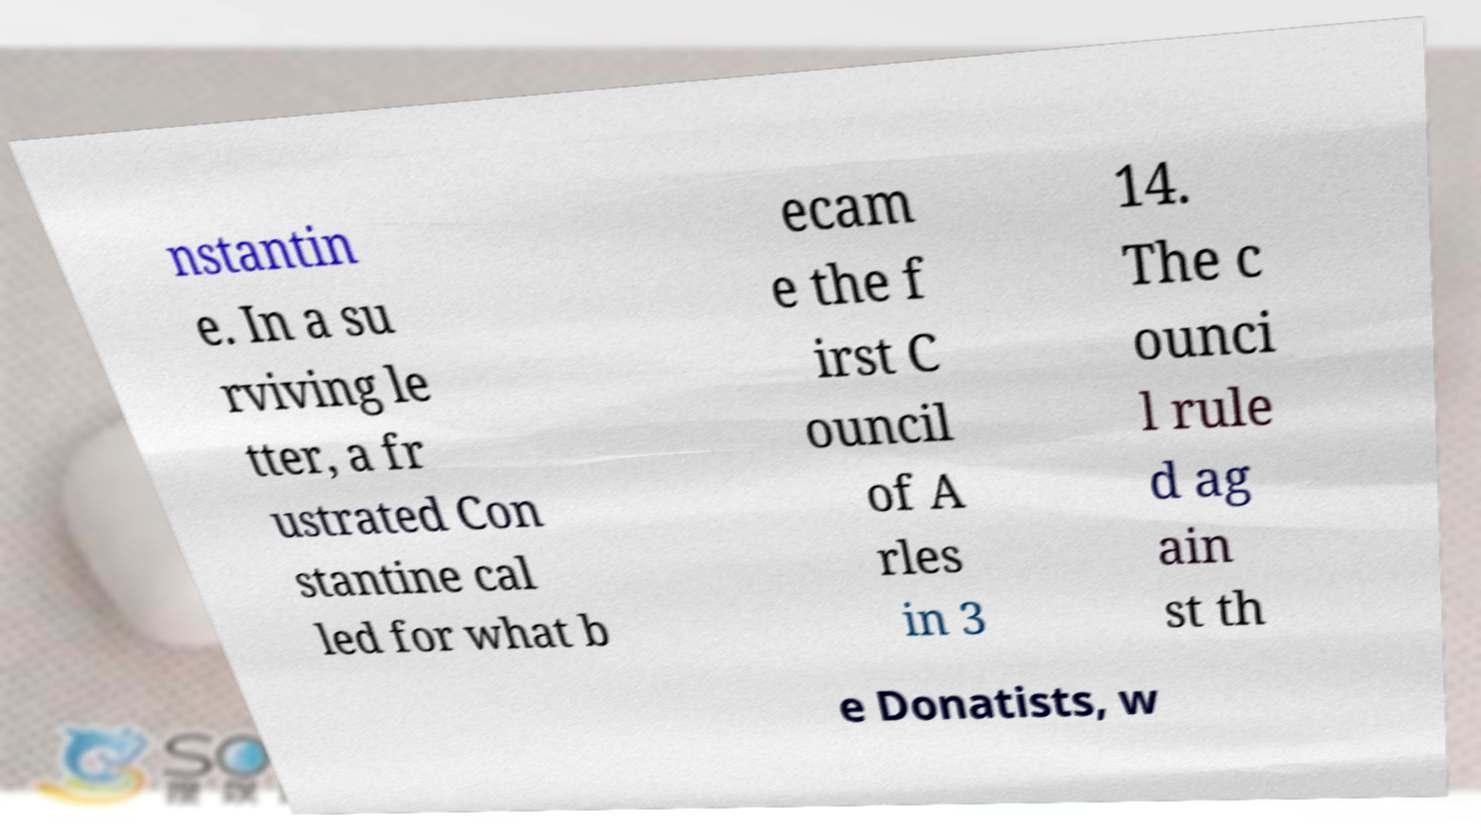Could you assist in decoding the text presented in this image and type it out clearly? nstantin e. In a su rviving le tter, a fr ustrated Con stantine cal led for what b ecam e the f irst C ouncil of A rles in 3 14. The c ounci l rule d ag ain st th e Donatists, w 